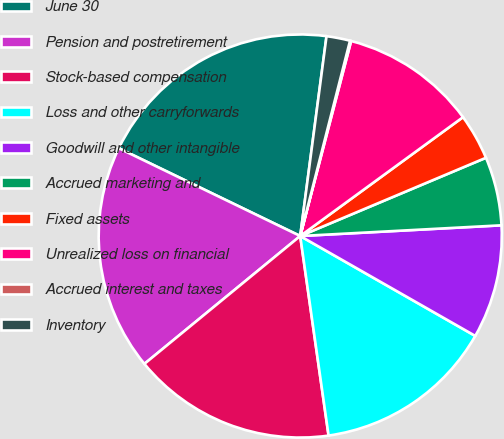<chart> <loc_0><loc_0><loc_500><loc_500><pie_chart><fcel>June 30<fcel>Pension and postretirement<fcel>Stock-based compensation<fcel>Loss and other carryforwards<fcel>Goodwill and other intangible<fcel>Accrued marketing and<fcel>Fixed assets<fcel>Unrealized loss on financial<fcel>Accrued interest and taxes<fcel>Inventory<nl><fcel>19.91%<fcel>18.11%<fcel>16.31%<fcel>14.5%<fcel>9.1%<fcel>5.5%<fcel>3.69%<fcel>10.9%<fcel>0.09%<fcel>1.89%<nl></chart> 